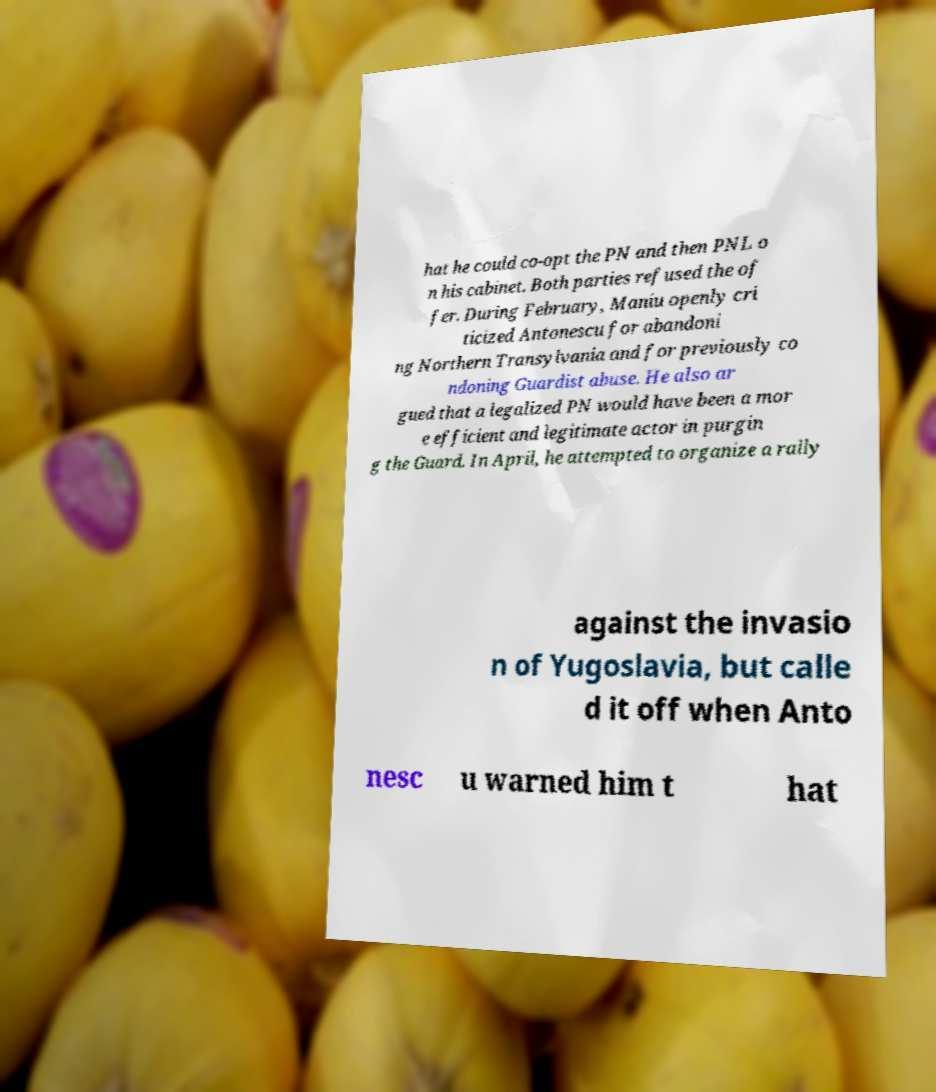For documentation purposes, I need the text within this image transcribed. Could you provide that? hat he could co-opt the PN and then PNL o n his cabinet. Both parties refused the of fer. During February, Maniu openly cri ticized Antonescu for abandoni ng Northern Transylvania and for previously co ndoning Guardist abuse. He also ar gued that a legalized PN would have been a mor e efficient and legitimate actor in purgin g the Guard. In April, he attempted to organize a rally against the invasio n of Yugoslavia, but calle d it off when Anto nesc u warned him t hat 